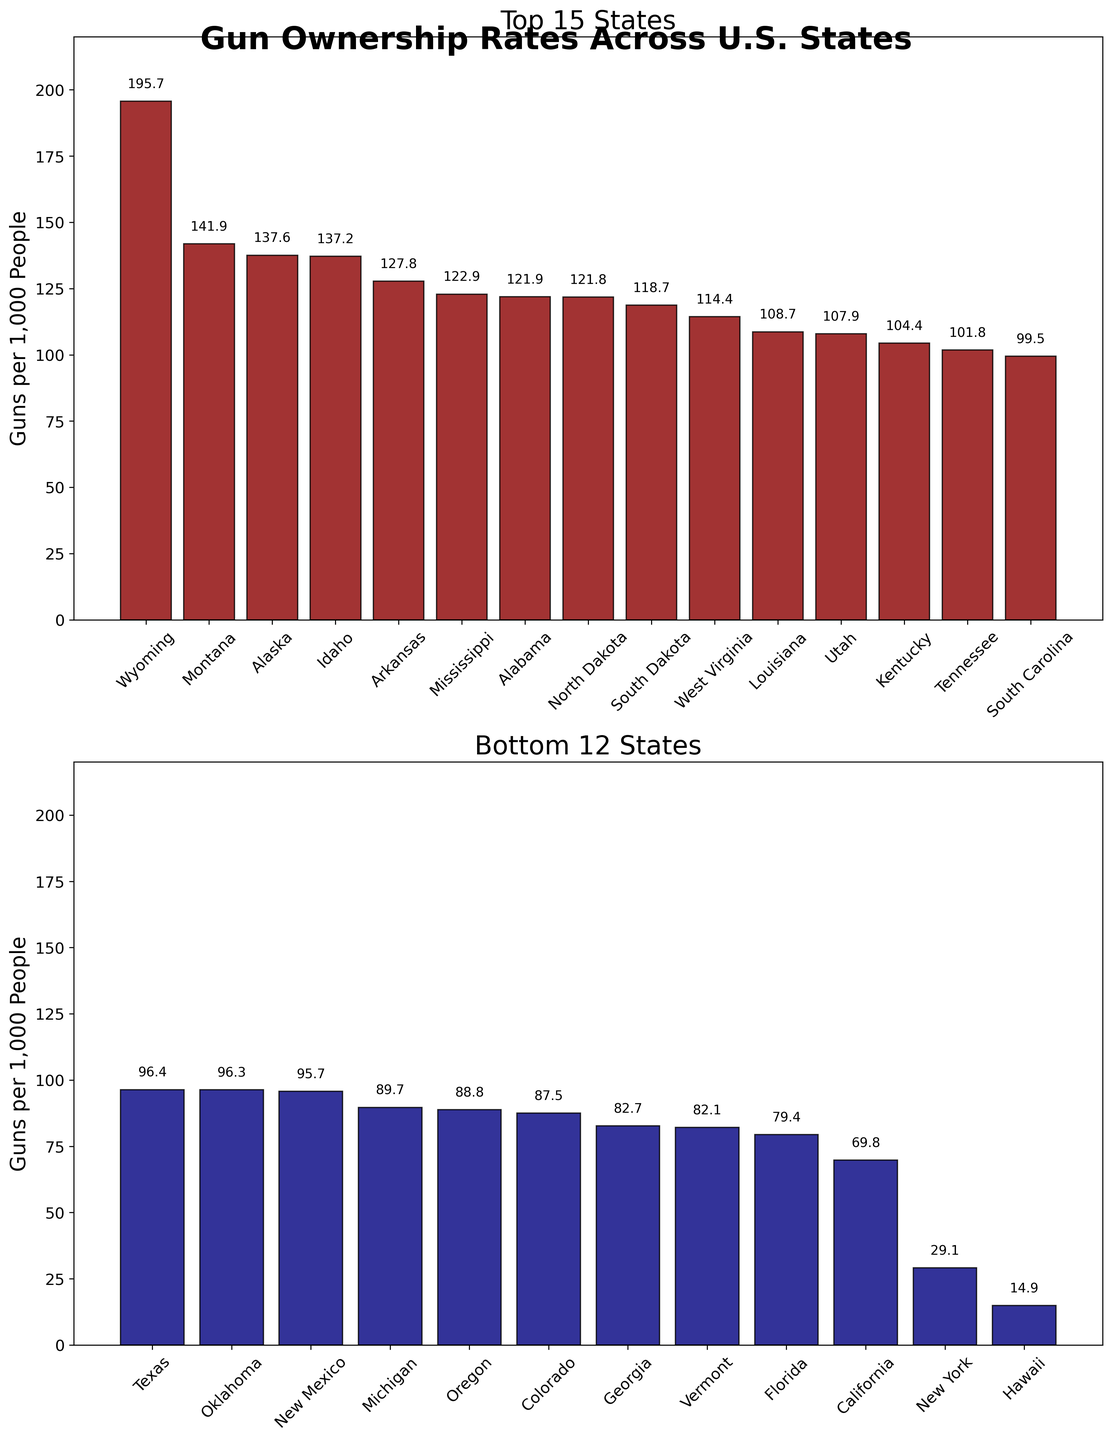Which state has the highest gun ownership rate per capita? The bar chart of the top 15 states shows Wyoming at the highest bar.
Answer: Wyoming Which state has the lowest gun ownership rate per capita? The bar chart of the bottom 12 states shows Hawaii at the lowest bar.
Answer: Hawaii What is the gun ownership rate per capita for Texas? In the bar chart of the top 15 states, look for the bar labeled "Texas" and check the value at the top of the bar.
Answer: 96.4 How many states have a gun ownership rate per capita of more than 100 guns per 1,000 people in the top 15 states? Count the bars in the top 15 states chart that are above the 100 mark.
Answer: 11 Which state out of the bottom 12 has the highest gun ownership rate per capita? Among the bottom 12 states, check for the tallest bar.
Answer: Michigan Compare the gun ownership rates of Mississippi and Vermont. Which state has a higher rate? Mississippi is in the top 15 states with a higher bar than Vermont, which is in the bottom 12 states.
Answer: Mississippi What is the average gun ownership rate per capita among the top 3 states? Add the rates of Wyoming (195.7), Montana (141.9), and Alaska (137.6) and divide by 3. (195.7 + 141.9 + 137.6) / 3 = 158.4
Answer: 158.4 What is the difference in gun ownership rates between the state with the highest rate and the state with the lowest rate? Subtract the lowest rate (Hawaii, 14.9) from the highest rate (Wyoming, 195.7). 195.7 - 14.9 = 180.8
Answer: 180.8 For the state with the median rate in the top 15, what is its gun ownership rate? The median state in the top 15 list is the 8th state, North Dakota, with a rate of 121.8.
Answer: 121.8 